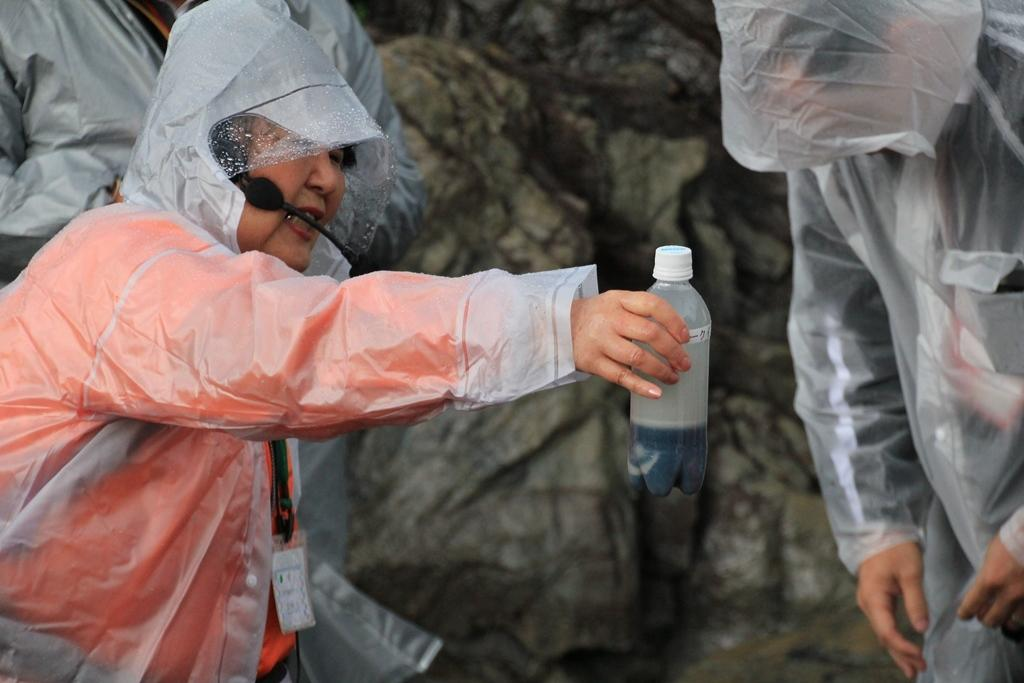How many people are in the image? There are three people in the image. What are the people wearing? The people are wearing raincoats. Can you describe the clothing of one of the people? One person is wearing a red dress. What is the person in the red dress holding? The person in the red dress is holding a bottle. What is the background of the people in the image? The background of the people is a rock. What type of comb is the person in the red dress using in the image? There is no comb present in the image. Can you tell me how many bats are flying around the person in the red dress? There are no bats present in the image. 